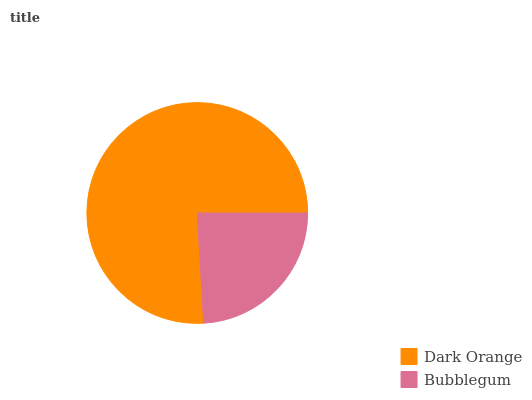Is Bubblegum the minimum?
Answer yes or no. Yes. Is Dark Orange the maximum?
Answer yes or no. Yes. Is Bubblegum the maximum?
Answer yes or no. No. Is Dark Orange greater than Bubblegum?
Answer yes or no. Yes. Is Bubblegum less than Dark Orange?
Answer yes or no. Yes. Is Bubblegum greater than Dark Orange?
Answer yes or no. No. Is Dark Orange less than Bubblegum?
Answer yes or no. No. Is Dark Orange the high median?
Answer yes or no. Yes. Is Bubblegum the low median?
Answer yes or no. Yes. Is Bubblegum the high median?
Answer yes or no. No. Is Dark Orange the low median?
Answer yes or no. No. 